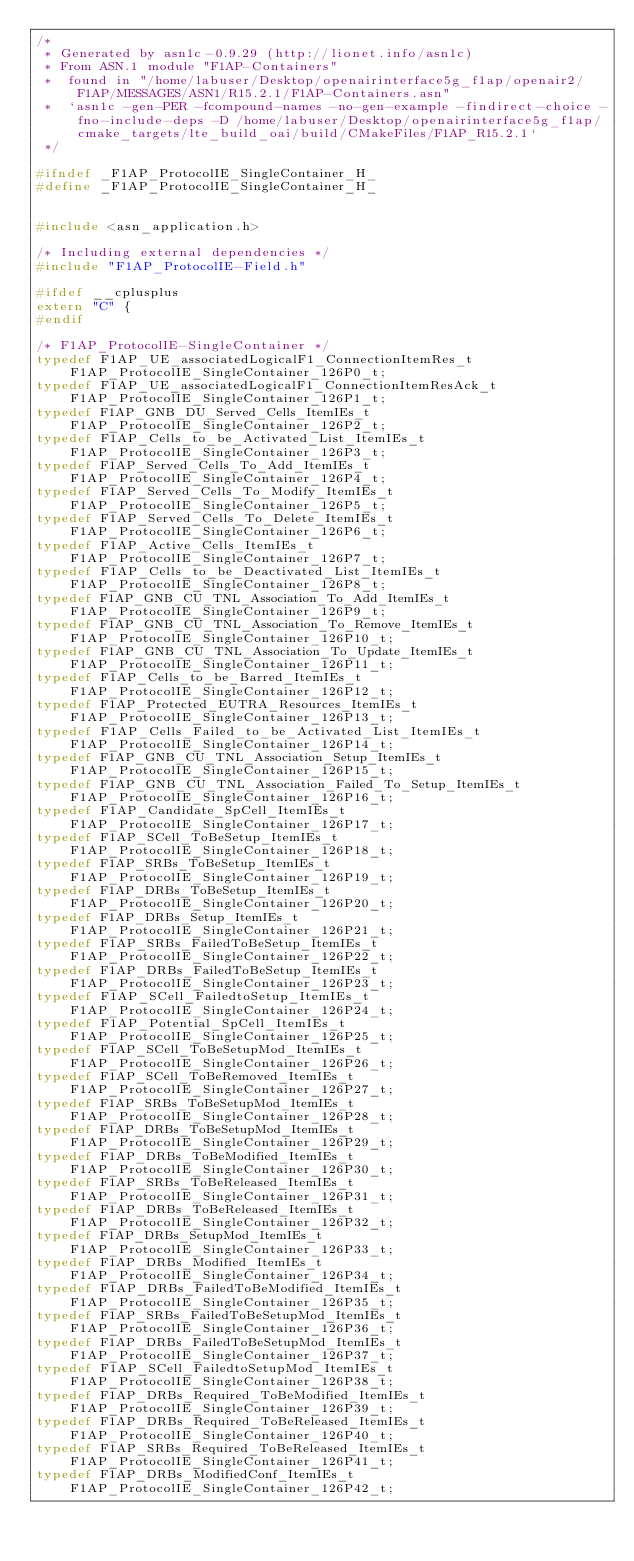<code> <loc_0><loc_0><loc_500><loc_500><_C_>/*
 * Generated by asn1c-0.9.29 (http://lionet.info/asn1c)
 * From ASN.1 module "F1AP-Containers"
 * 	found in "/home/labuser/Desktop/openairinterface5g_f1ap/openair2/F1AP/MESSAGES/ASN1/R15.2.1/F1AP-Containers.asn"
 * 	`asn1c -gen-PER -fcompound-names -no-gen-example -findirect-choice -fno-include-deps -D /home/labuser/Desktop/openairinterface5g_f1ap/cmake_targets/lte_build_oai/build/CMakeFiles/F1AP_R15.2.1`
 */

#ifndef	_F1AP_ProtocolIE_SingleContainer_H_
#define	_F1AP_ProtocolIE_SingleContainer_H_


#include <asn_application.h>

/* Including external dependencies */
#include "F1AP_ProtocolIE-Field.h"

#ifdef __cplusplus
extern "C" {
#endif

/* F1AP_ProtocolIE-SingleContainer */
typedef F1AP_UE_associatedLogicalF1_ConnectionItemRes_t	 F1AP_ProtocolIE_SingleContainer_126P0_t;
typedef F1AP_UE_associatedLogicalF1_ConnectionItemResAck_t	 F1AP_ProtocolIE_SingleContainer_126P1_t;
typedef F1AP_GNB_DU_Served_Cells_ItemIEs_t	 F1AP_ProtocolIE_SingleContainer_126P2_t;
typedef F1AP_Cells_to_be_Activated_List_ItemIEs_t	 F1AP_ProtocolIE_SingleContainer_126P3_t;
typedef F1AP_Served_Cells_To_Add_ItemIEs_t	 F1AP_ProtocolIE_SingleContainer_126P4_t;
typedef F1AP_Served_Cells_To_Modify_ItemIEs_t	 F1AP_ProtocolIE_SingleContainer_126P5_t;
typedef F1AP_Served_Cells_To_Delete_ItemIEs_t	 F1AP_ProtocolIE_SingleContainer_126P6_t;
typedef F1AP_Active_Cells_ItemIEs_t	 F1AP_ProtocolIE_SingleContainer_126P7_t;
typedef F1AP_Cells_to_be_Deactivated_List_ItemIEs_t	 F1AP_ProtocolIE_SingleContainer_126P8_t;
typedef F1AP_GNB_CU_TNL_Association_To_Add_ItemIEs_t	 F1AP_ProtocolIE_SingleContainer_126P9_t;
typedef F1AP_GNB_CU_TNL_Association_To_Remove_ItemIEs_t	 F1AP_ProtocolIE_SingleContainer_126P10_t;
typedef F1AP_GNB_CU_TNL_Association_To_Update_ItemIEs_t	 F1AP_ProtocolIE_SingleContainer_126P11_t;
typedef F1AP_Cells_to_be_Barred_ItemIEs_t	 F1AP_ProtocolIE_SingleContainer_126P12_t;
typedef F1AP_Protected_EUTRA_Resources_ItemIEs_t	 F1AP_ProtocolIE_SingleContainer_126P13_t;
typedef F1AP_Cells_Failed_to_be_Activated_List_ItemIEs_t	 F1AP_ProtocolIE_SingleContainer_126P14_t;
typedef F1AP_GNB_CU_TNL_Association_Setup_ItemIEs_t	 F1AP_ProtocolIE_SingleContainer_126P15_t;
typedef F1AP_GNB_CU_TNL_Association_Failed_To_Setup_ItemIEs_t	 F1AP_ProtocolIE_SingleContainer_126P16_t;
typedef F1AP_Candidate_SpCell_ItemIEs_t	 F1AP_ProtocolIE_SingleContainer_126P17_t;
typedef F1AP_SCell_ToBeSetup_ItemIEs_t	 F1AP_ProtocolIE_SingleContainer_126P18_t;
typedef F1AP_SRBs_ToBeSetup_ItemIEs_t	 F1AP_ProtocolIE_SingleContainer_126P19_t;
typedef F1AP_DRBs_ToBeSetup_ItemIEs_t	 F1AP_ProtocolIE_SingleContainer_126P20_t;
typedef F1AP_DRBs_Setup_ItemIEs_t	 F1AP_ProtocolIE_SingleContainer_126P21_t;
typedef F1AP_SRBs_FailedToBeSetup_ItemIEs_t	 F1AP_ProtocolIE_SingleContainer_126P22_t;
typedef F1AP_DRBs_FailedToBeSetup_ItemIEs_t	 F1AP_ProtocolIE_SingleContainer_126P23_t;
typedef F1AP_SCell_FailedtoSetup_ItemIEs_t	 F1AP_ProtocolIE_SingleContainer_126P24_t;
typedef F1AP_Potential_SpCell_ItemIEs_t	 F1AP_ProtocolIE_SingleContainer_126P25_t;
typedef F1AP_SCell_ToBeSetupMod_ItemIEs_t	 F1AP_ProtocolIE_SingleContainer_126P26_t;
typedef F1AP_SCell_ToBeRemoved_ItemIEs_t	 F1AP_ProtocolIE_SingleContainer_126P27_t;
typedef F1AP_SRBs_ToBeSetupMod_ItemIEs_t	 F1AP_ProtocolIE_SingleContainer_126P28_t;
typedef F1AP_DRBs_ToBeSetupMod_ItemIEs_t	 F1AP_ProtocolIE_SingleContainer_126P29_t;
typedef F1AP_DRBs_ToBeModified_ItemIEs_t	 F1AP_ProtocolIE_SingleContainer_126P30_t;
typedef F1AP_SRBs_ToBeReleased_ItemIEs_t	 F1AP_ProtocolIE_SingleContainer_126P31_t;
typedef F1AP_DRBs_ToBeReleased_ItemIEs_t	 F1AP_ProtocolIE_SingleContainer_126P32_t;
typedef F1AP_DRBs_SetupMod_ItemIEs_t	 F1AP_ProtocolIE_SingleContainer_126P33_t;
typedef F1AP_DRBs_Modified_ItemIEs_t	 F1AP_ProtocolIE_SingleContainer_126P34_t;
typedef F1AP_DRBs_FailedToBeModified_ItemIEs_t	 F1AP_ProtocolIE_SingleContainer_126P35_t;
typedef F1AP_SRBs_FailedToBeSetupMod_ItemIEs_t	 F1AP_ProtocolIE_SingleContainer_126P36_t;
typedef F1AP_DRBs_FailedToBeSetupMod_ItemIEs_t	 F1AP_ProtocolIE_SingleContainer_126P37_t;
typedef F1AP_SCell_FailedtoSetupMod_ItemIEs_t	 F1AP_ProtocolIE_SingleContainer_126P38_t;
typedef F1AP_DRBs_Required_ToBeModified_ItemIEs_t	 F1AP_ProtocolIE_SingleContainer_126P39_t;
typedef F1AP_DRBs_Required_ToBeReleased_ItemIEs_t	 F1AP_ProtocolIE_SingleContainer_126P40_t;
typedef F1AP_SRBs_Required_ToBeReleased_ItemIEs_t	 F1AP_ProtocolIE_SingleContainer_126P41_t;
typedef F1AP_DRBs_ModifiedConf_ItemIEs_t	 F1AP_ProtocolIE_SingleContainer_126P42_t;</code> 